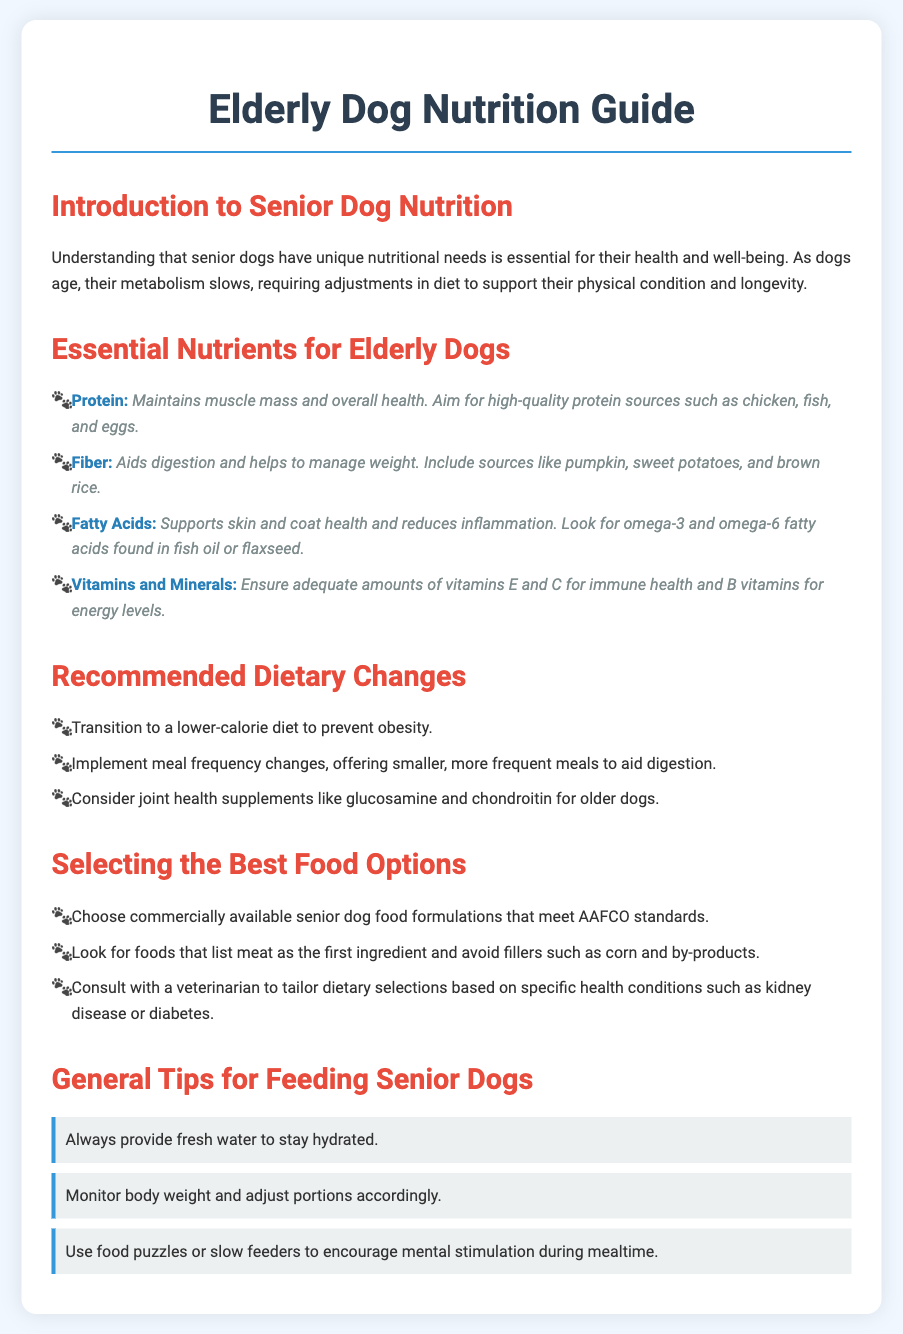What are the essential nutrients for elderly dogs? The document lists the essential nutrients specifically for elderly dogs under the "Essential Nutrients for Elderly Dogs" section.
Answer: Protein, Fiber, Fatty Acids, Vitamins and Minerals What should be the first ingredient in dog food? The document specifies that for selecting the best food options, foods should list meat as the first ingredient.
Answer: Meat Which fatty acids are important for elderly dogs? The document mentions omega-3 and omega-6 fatty acids as important for elderly dogs.
Answer: omega-3 and omega-6 What dietary change is recommended to prevent obesity in senior dogs? The document advises transitioning to a lower-calorie diet to prevent obesity.
Answer: Lower-calorie diet How many meals are suggested for elderly dogs? The document suggests offering smaller, more frequent meals to aid digestion.
Answer: Smaller, more frequent meals What supplements are considered for joint health in older dogs? The document includes glucosamine and chondroitin as joint health supplements for older dogs.
Answer: Glucosamine and chondroitin What is the significance of vitamins E and C? The document states that vitamins E and C are important for immune health in elderly dogs.
Answer: Immune health What should you ensure is provided alongside meals for senior dogs? The document emphasizes always providing fresh water to senior dogs.
Answer: Fresh water 